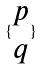Convert formula to latex. <formula><loc_0><loc_0><loc_500><loc_500>\{ \begin{matrix} p \\ q \end{matrix} \}</formula> 